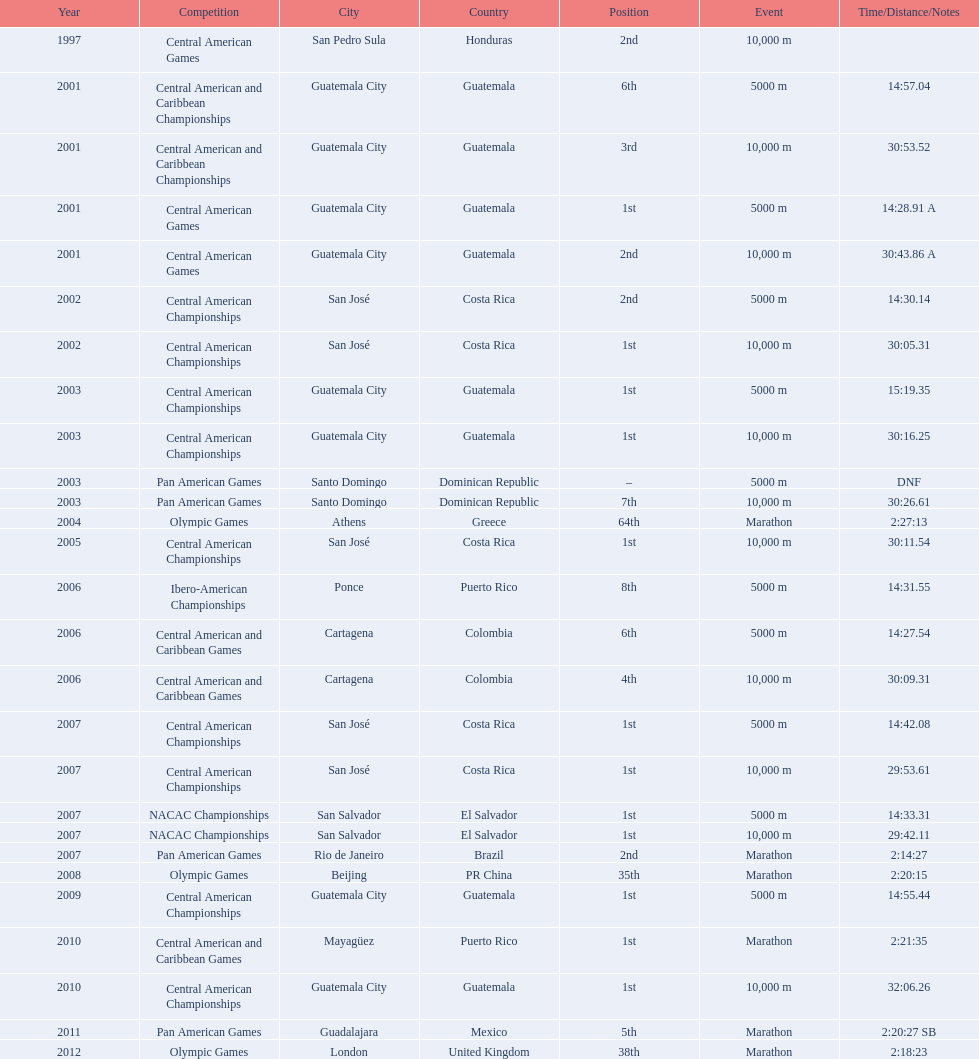How many times has this athlete not finished in a competition? 1. 